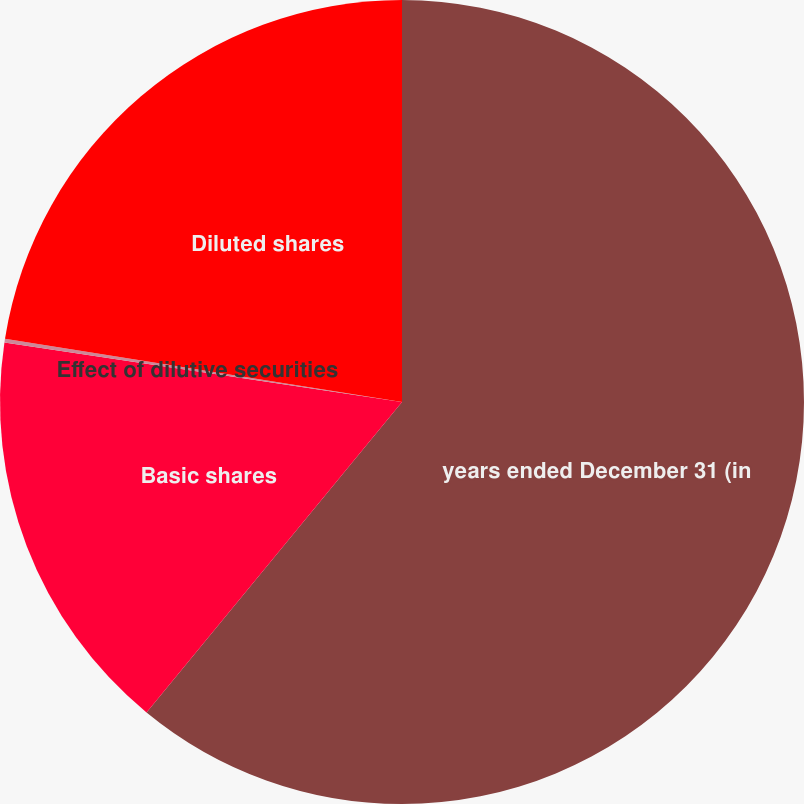Convert chart. <chart><loc_0><loc_0><loc_500><loc_500><pie_chart><fcel>years ended December 31 (in<fcel>Basic shares<fcel>Effect of dilutive securities<fcel>Diluted shares<nl><fcel>60.96%<fcel>16.4%<fcel>0.15%<fcel>22.49%<nl></chart> 